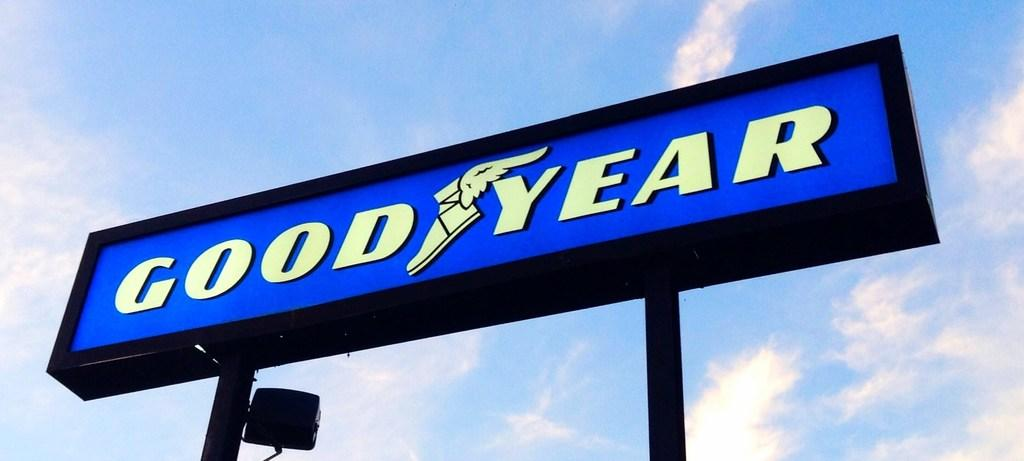<image>
Share a concise interpretation of the image provided. Good Year has a flying shoe logo on a blue sign. 